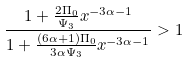<formula> <loc_0><loc_0><loc_500><loc_500>\frac { 1 + \frac { 2 \Pi _ { 0 } } { \Psi _ { 3 } } x ^ { - 3 \alpha - 1 } } { 1 + \frac { ( 6 \alpha + 1 ) \Pi _ { 0 } } { 3 \alpha \Psi _ { 3 } } x ^ { - 3 \alpha - 1 } } > 1</formula> 